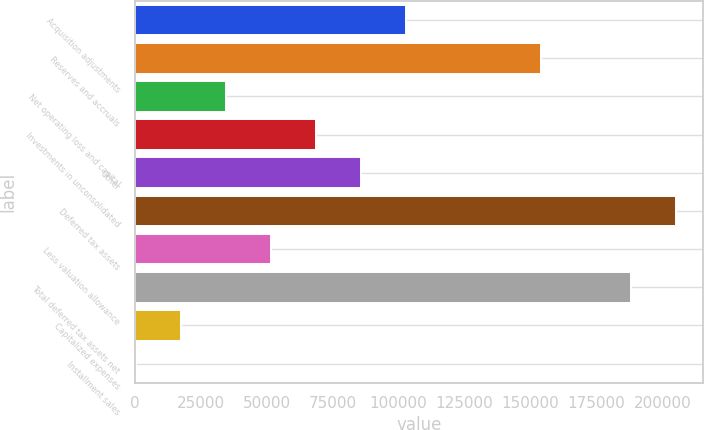Convert chart to OTSL. <chart><loc_0><loc_0><loc_500><loc_500><bar_chart><fcel>Acquisition adjustments<fcel>Reserves and accruals<fcel>Net operating loss and capital<fcel>Investments in unconsolidated<fcel>Other<fcel>Deferred tax assets<fcel>Less valuation allowance<fcel>Total deferred tax assets net<fcel>Capitalized expenses<fcel>Installment sales<nl><fcel>102937<fcel>154057<fcel>34777.8<fcel>68857.6<fcel>85897.5<fcel>205177<fcel>51817.7<fcel>188137<fcel>17737.9<fcel>698<nl></chart> 